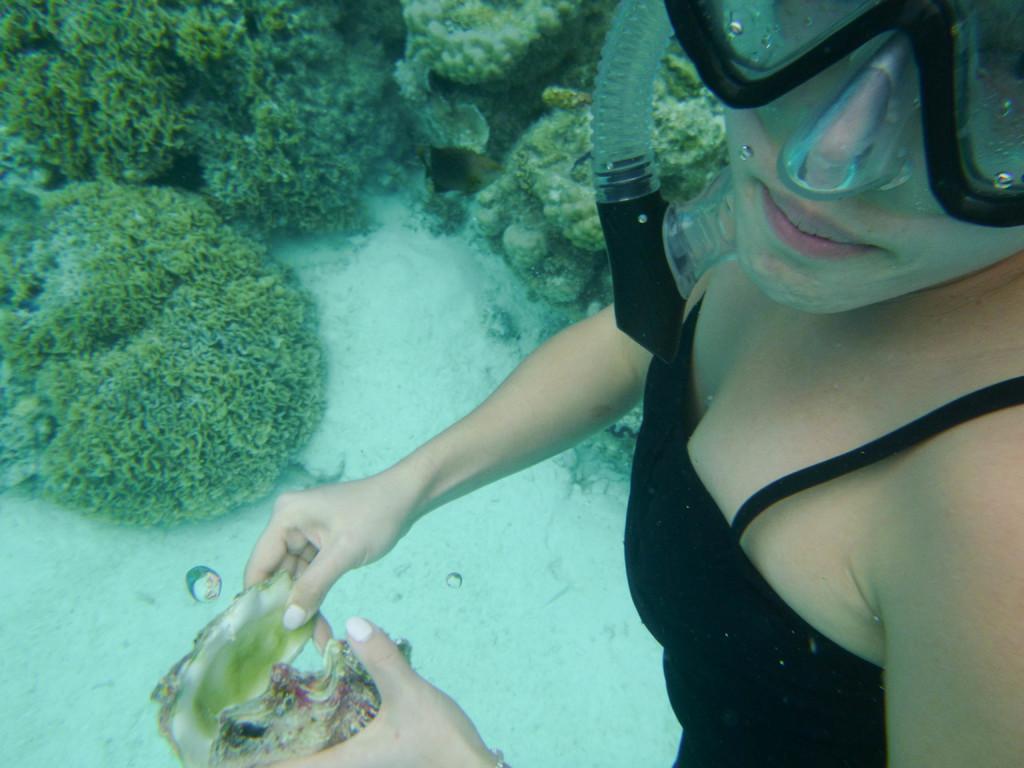Could you give a brief overview of what you see in this image? This image consists of a woman wearing a black dress. She is holding a shell. At the bottom, we can see the small plants in the water. And she is also wearing an oxygen mask. 